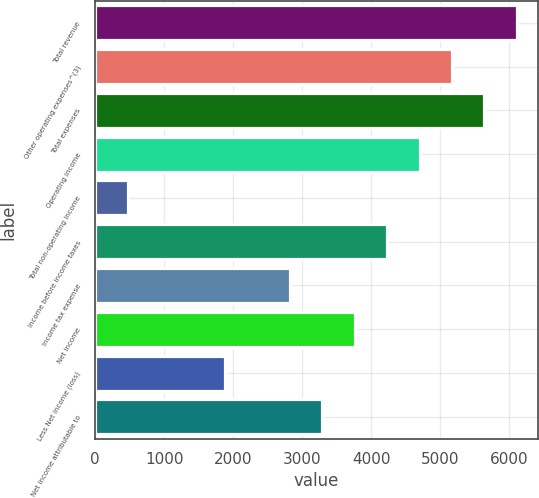Convert chart to OTSL. <chart><loc_0><loc_0><loc_500><loc_500><bar_chart><fcel>Total revenue<fcel>Other operating expenses^(3)<fcel>Total expenses<fcel>Operating income<fcel>Total non-operating income<fcel>Income before income taxes<fcel>Income tax expense<fcel>Net income<fcel>Less Net income (loss)<fcel>Net income attributable to<nl><fcel>6109.09<fcel>5169.71<fcel>5639.4<fcel>4700.02<fcel>472.81<fcel>4230.33<fcel>2821.26<fcel>3760.64<fcel>1881.88<fcel>3290.95<nl></chart> 